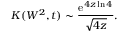Convert formula to latex. <formula><loc_0><loc_0><loc_500><loc_500>K ( W ^ { 2 } , t ) \sim { \frac { e ^ { 4 z \ln { 4 } } } { \sqrt { 4 z } } } .</formula> 